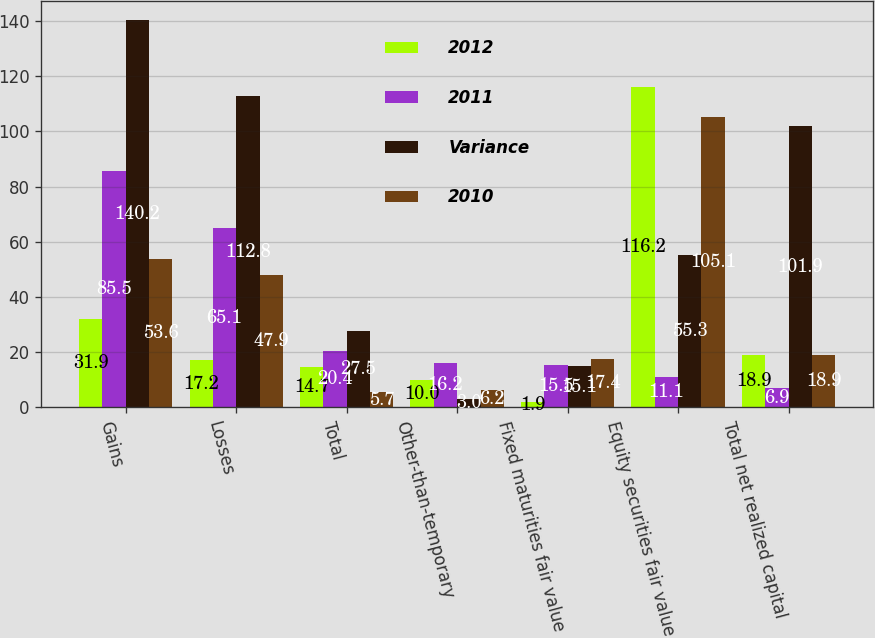Convert chart to OTSL. <chart><loc_0><loc_0><loc_500><loc_500><stacked_bar_chart><ecel><fcel>Gains<fcel>Losses<fcel>Total<fcel>Other-than-temporary<fcel>Fixed maturities fair value<fcel>Equity securities fair value<fcel>Total net realized capital<nl><fcel>2012<fcel>31.9<fcel>17.2<fcel>14.7<fcel>10<fcel>1.9<fcel>116.2<fcel>18.9<nl><fcel>2011<fcel>85.5<fcel>65.1<fcel>20.4<fcel>16.2<fcel>15.5<fcel>11.1<fcel>6.9<nl><fcel>Variance<fcel>140.2<fcel>112.8<fcel>27.5<fcel>3<fcel>15.1<fcel>55.3<fcel>101.9<nl><fcel>2010<fcel>53.6<fcel>47.9<fcel>5.7<fcel>6.2<fcel>17.4<fcel>105.1<fcel>18.9<nl></chart> 